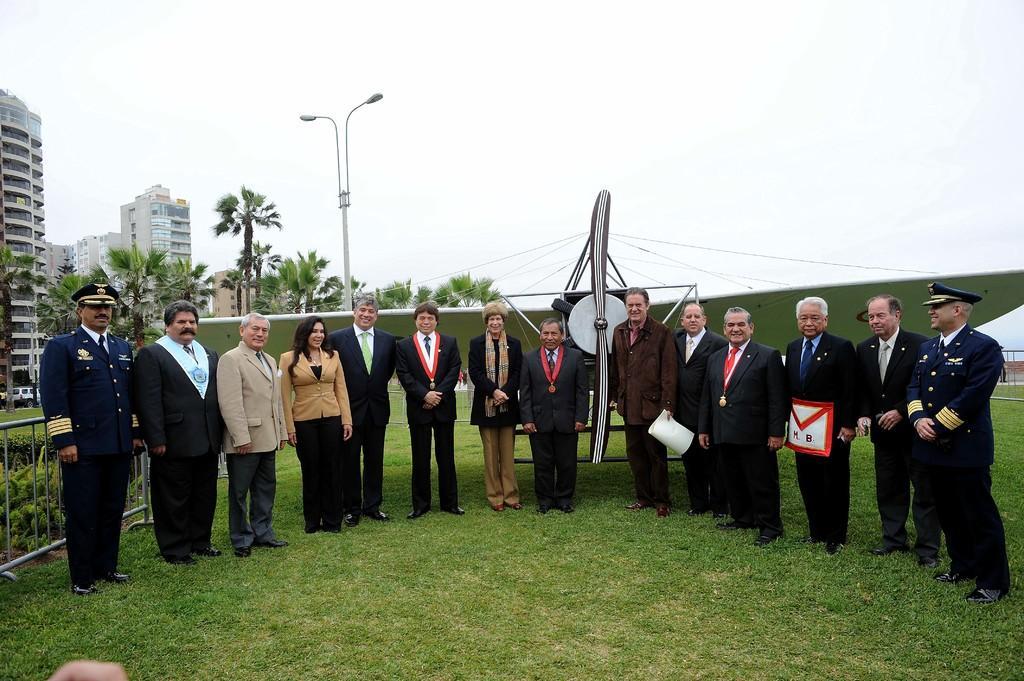Could you give a brief overview of what you see in this image? In this image I can see number of people are standing on ground. I can also see few of them are wearing uniforms and rest all are wearing suit, tie and shirt. In the background I can see an aircraft, a pole, few lights, number of trees, buildings and grass. 